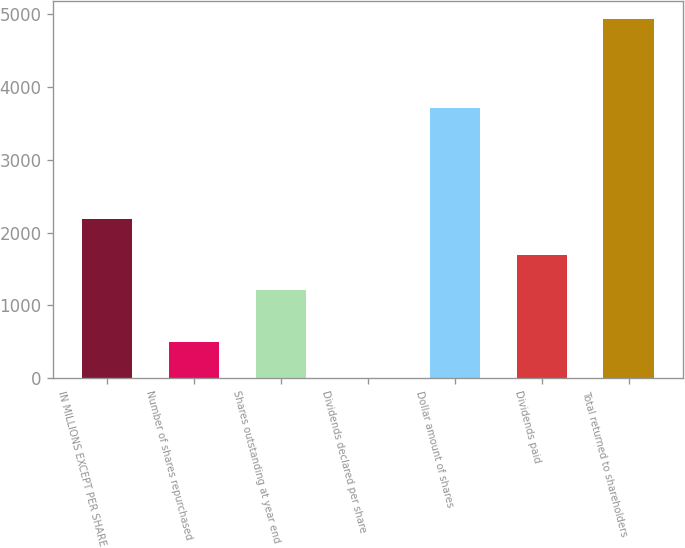<chart> <loc_0><loc_0><loc_500><loc_500><bar_chart><fcel>IN MILLIONS EXCEPT PER SHARE<fcel>Number of shares repurchased<fcel>Shares outstanding at year end<fcel>Dividends declared per share<fcel>Dollar amount of shares<fcel>Dividends paid<fcel>Total returned to shareholders<nl><fcel>2191<fcel>494.5<fcel>1204<fcel>1<fcel>3719<fcel>1697.5<fcel>4936<nl></chart> 